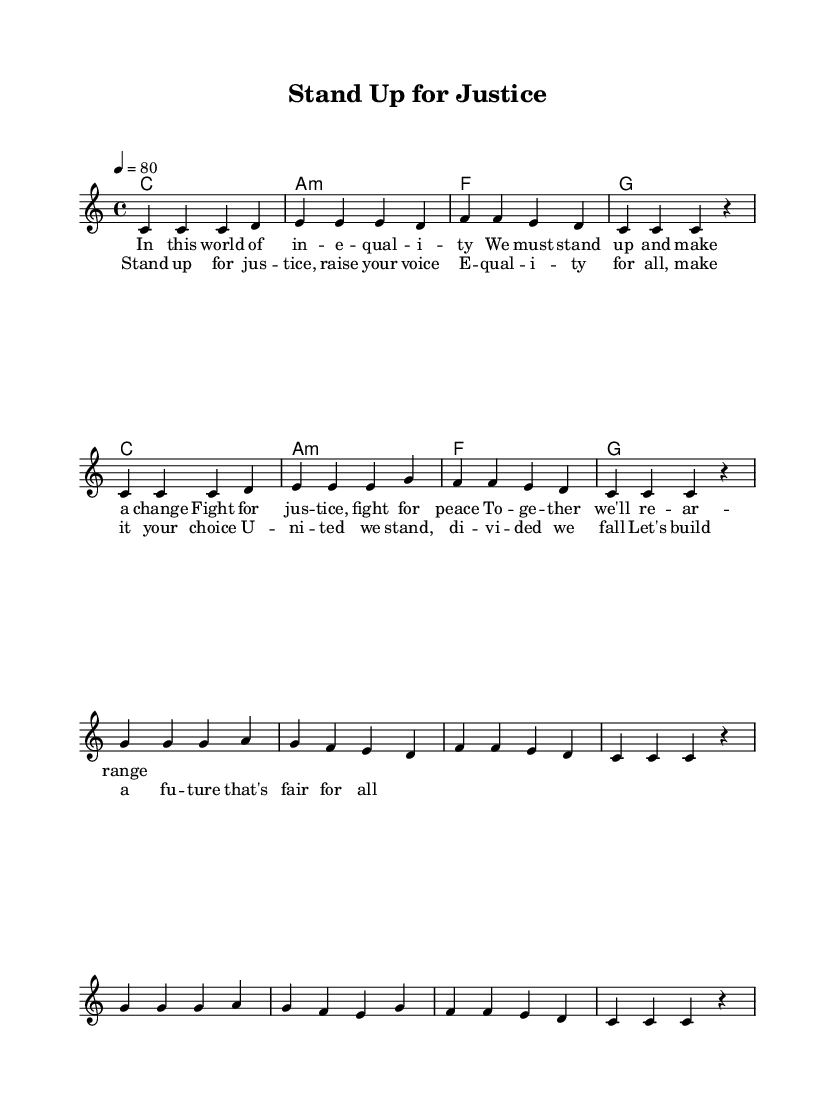What is the key signature of this music? The key signature is C major, which has no sharps or flats indicated on the staff.
Answer: C major What is the time signature of this music? The time signature is indicated as 4/4 at the beginning of the score, meaning there are four beats in each measure.
Answer: 4/4 What is the tempo marking for this piece? The tempo is marked as a quarter note equals 80 beats per minute, indicated at the beginning of the score.
Answer: 80 How many verses are in the song? The lyrics provided indicate that there is one verse followed by a chorus, suggesting a structure with one complete verse.
Answer: One What is the main theme of the lyrics? By analyzing the content of the lyrics, the main theme focuses on justice, equality, and unity in the fight against inequality in society.
Answer: Justice, equality What chord follows the A minor chord in the progression? The chord progression shows that the A minor chord is followed by the F major chord, which directly follows it in the harmonies section.
Answer: F How does the chorus emphasize the message of equality? The chorus repeats the phrase 'Stand up for justice, raise your voice' and uses the challenge of division versus unity, enhancing the message of collective action for equality.
Answer: By repeating key phrases 